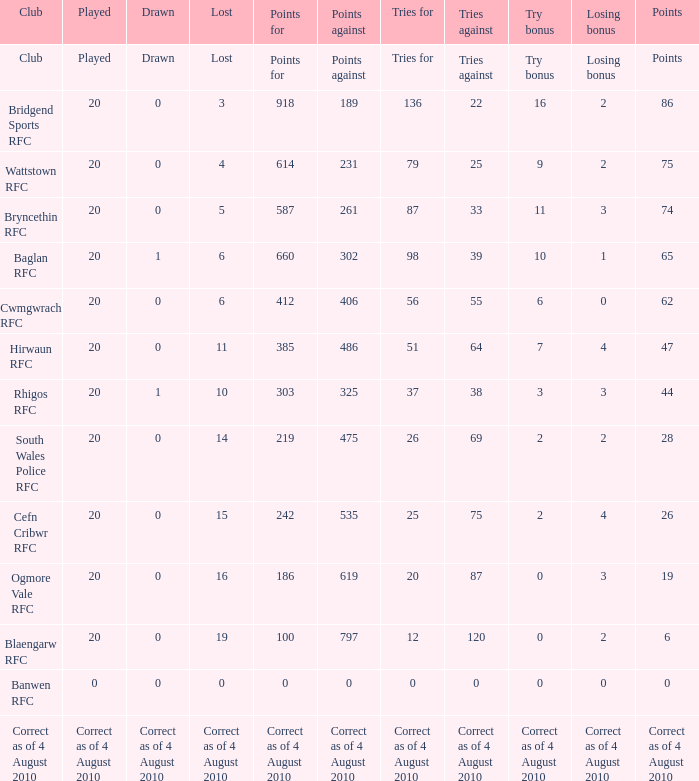What is lost when the points against is 231? 4.0. 